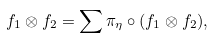Convert formula to latex. <formula><loc_0><loc_0><loc_500><loc_500>f _ { 1 } \otimes f _ { 2 } = \sum \pi _ { \eta } \circ ( f _ { 1 } \otimes f _ { 2 } ) , \\</formula> 